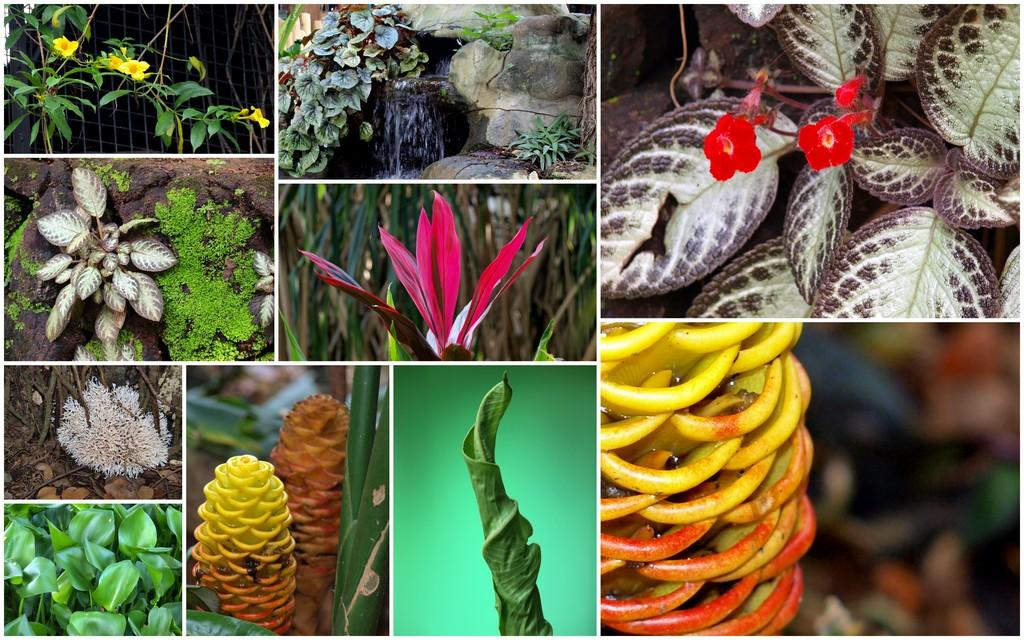What type of artwork is depicted in the image? The image is a collage. What natural elements can be seen in the collage? There are plants and flowers in the collage. What type of attraction is depicted in the collage? There is no attraction present in the collage; it features plants and flowers. What nerve is responsible for the movement of the flowers in the collage? The flowers in the collage are not moving, and there is no mention of nerves in the image. --- Facts: 1. There is a car in the image. 2. The car is red. 3. The car has four wheels. 4. There is a road in the image. 5. The road is paved. Absurd Topics: parrot, ocean, volcano Conversation: What is the main subject of the image? The main subject of the image is a car. What color is the car? The car is red. How many wheels does the car have? The car has four wheels. What type of surface can be seen in the image? There is a paved road in the image. Reasoning: Let's think step by step in order to produce the conversation. We start by identifying the main subject of the image, which is the car. Then, we describe specific features of the car, such as its color and the number of wheels. Next, we observe the setting in which the car is located, noting that there is a paved road. Each question is designed to elicit a specific detail about the image that is known from the provided facts. Absurd Question/Answer: Can you see a parrot flying over the car in the image? There is no parrot present in the image; it features a red car and a paved road. Is there an active volcano visible in the background of the image? There is no volcano present in the image; it features a red car and a paved road. 